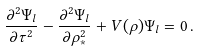Convert formula to latex. <formula><loc_0><loc_0><loc_500><loc_500>\frac { \partial ^ { 2 } \Psi _ { l } } { \partial \tau ^ { 2 } } - \frac { \partial ^ { 2 } \Psi _ { l } } { \partial \rho ^ { 2 } _ { * } } + V ( \rho ) \Psi _ { l } = 0 \, .</formula> 